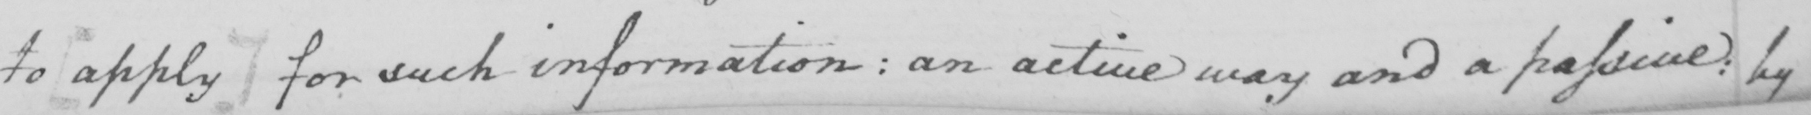Please provide the text content of this handwritten line. to [apply] for such information: an active way and a passive: by 